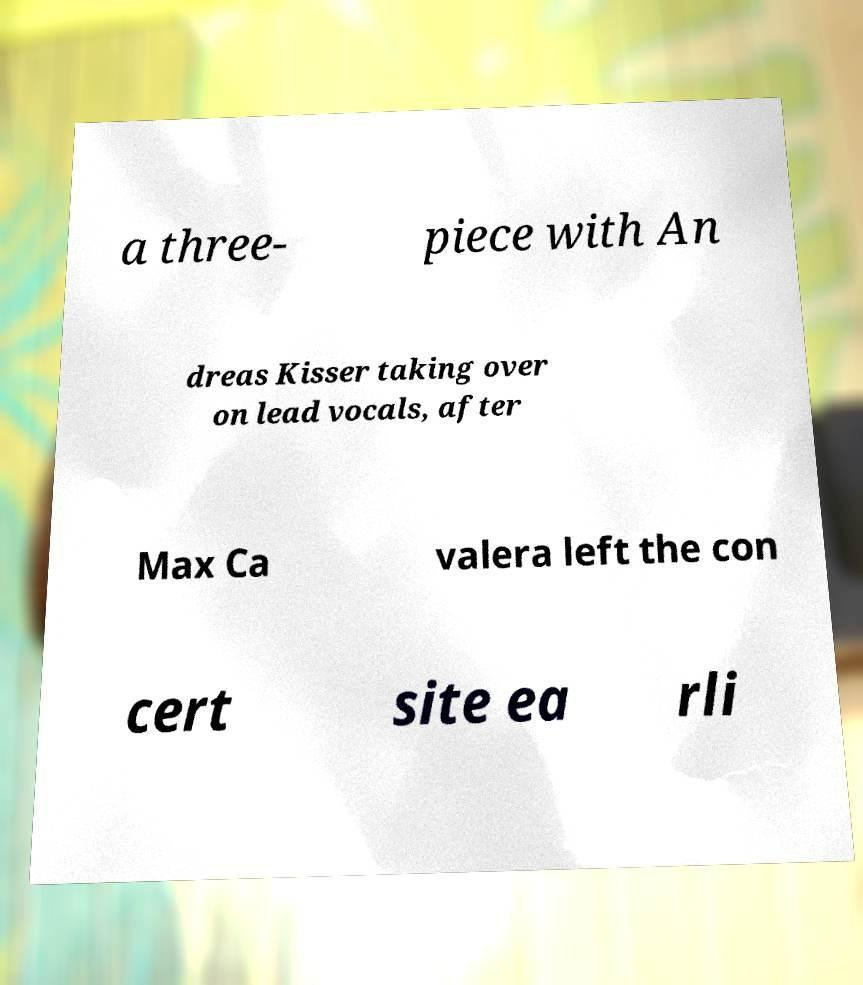Please identify and transcribe the text found in this image. a three- piece with An dreas Kisser taking over on lead vocals, after Max Ca valera left the con cert site ea rli 